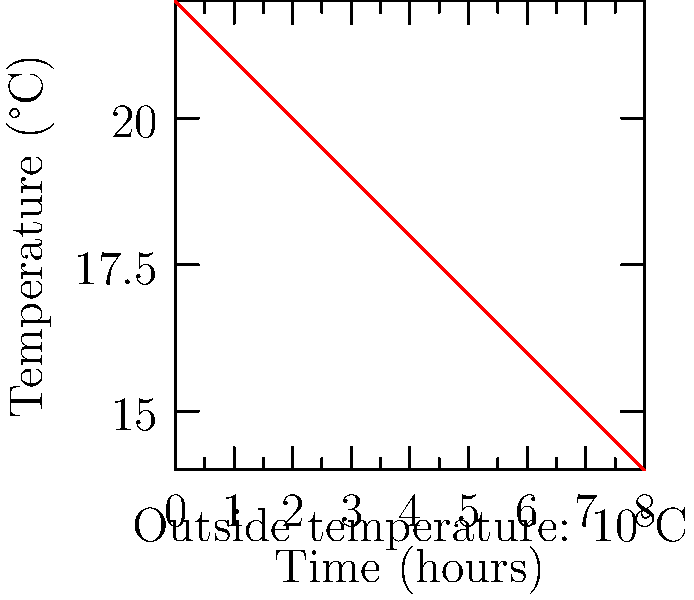The graph shows the temperature decline in a poorly insulated office building over 8 hours after the heating is turned off at 5 PM. The outside temperature remains constant at 10°C. Assuming Newton's Law of Cooling applies, estimate the time constant $\tau$ for this cooling process. To solve this problem, we'll use Newton's Law of Cooling and the concept of time constant:

1) Newton's Law of Cooling states that the rate of heat loss is proportional to the temperature difference between the object and its surroundings.

2) The solution to this law gives an exponential decay of temperature difference:

   $T(t) = T_s + (T_0 - T_s)e^{-t/\tau}$

   Where:
   $T(t)$ is the temperature at time $t$
   $T_s$ is the surrounding temperature (10°C)
   $T_0$ is the initial temperature (22°C)
   $\tau$ is the time constant

3) The time constant $\tau$ is the time it takes for the temperature difference to decrease to $1/e$ (about 36.8%) of its initial value.

4) From the graph, we can estimate:
   Initial temperature difference: $22°C - 10°C = 12°C$
   Temperature difference after 8 hours: $14°C - 10°C = 4°C$

5) The ratio of these differences is:
   $4°C / 12°C \approx 0.333$

6) This ratio should equal $e^{-t/\tau}$, where $t = 8$ hours:

   $e^{-8/\tau} = 0.333$

7) Taking the natural log of both sides:

   $-8/\tau = \ln(0.333)$

8) Solving for $\tau$:

   $\tau = -8 / \ln(0.333) \approx 7.3$ hours

Therefore, the estimated time constant for this cooling process is approximately 7.3 hours.
Answer: $\tau \approx 7.3$ hours 